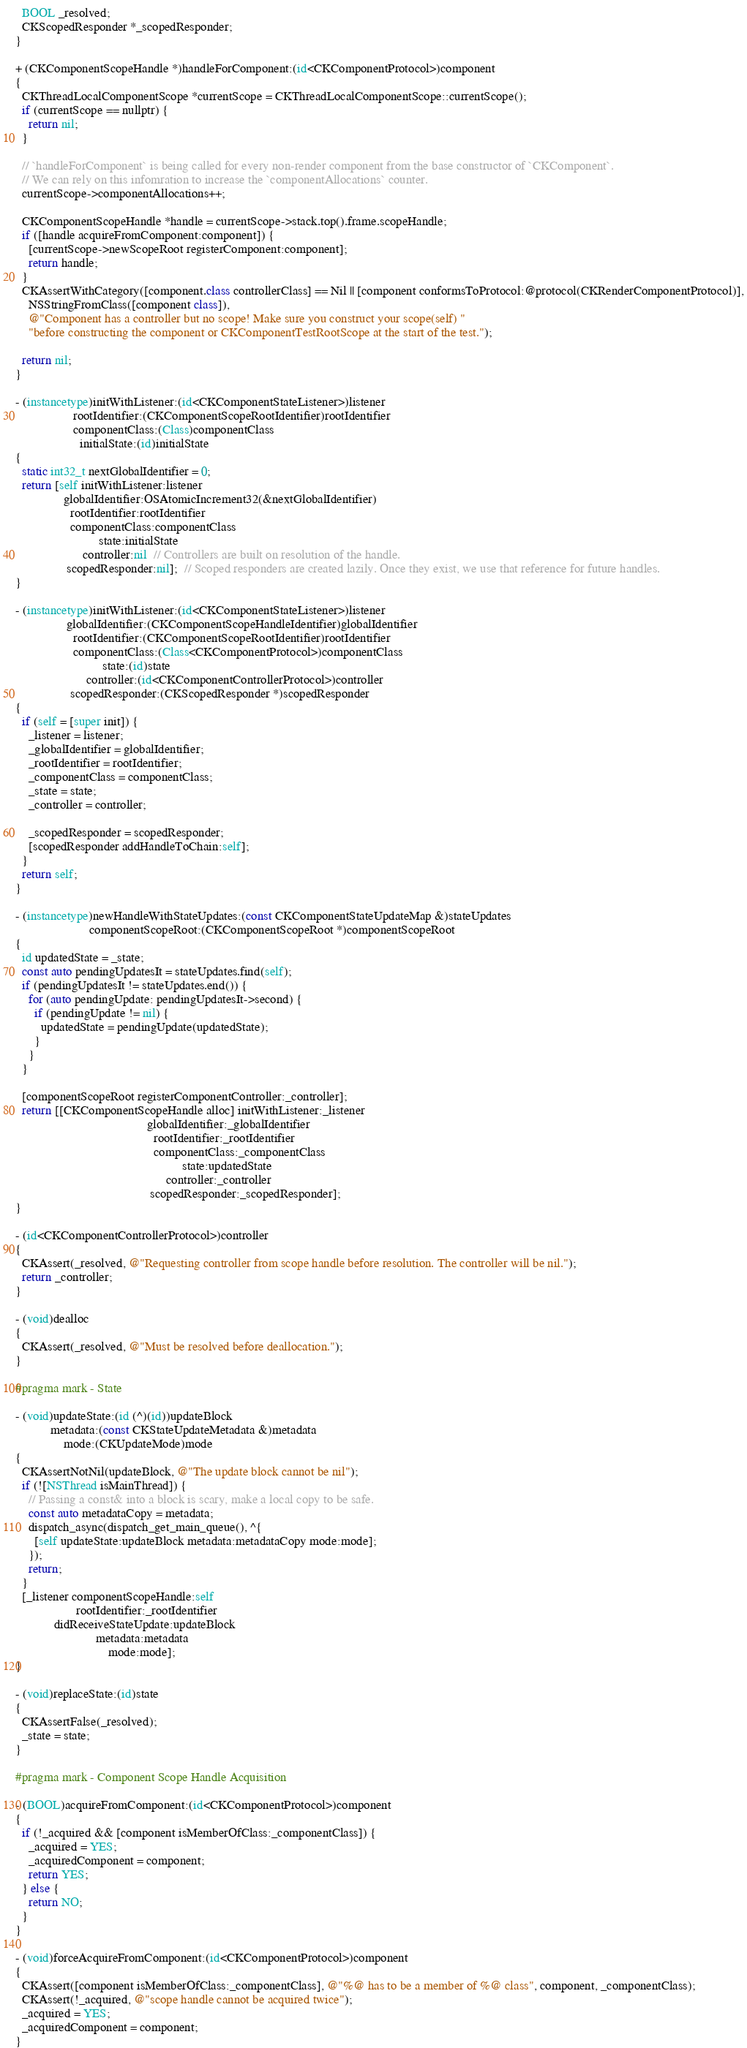<code> <loc_0><loc_0><loc_500><loc_500><_ObjectiveC_>  BOOL _resolved;
  CKScopedResponder *_scopedResponder;
}

+ (CKComponentScopeHandle *)handleForComponent:(id<CKComponentProtocol>)component
{
  CKThreadLocalComponentScope *currentScope = CKThreadLocalComponentScope::currentScope();
  if (currentScope == nullptr) {
    return nil;
  }

  // `handleForComponent` is being called for every non-render component from the base constructor of `CKComponent`.
  // We can rely on this infomration to increase the `componentAllocations` counter.
  currentScope->componentAllocations++;

  CKComponentScopeHandle *handle = currentScope->stack.top().frame.scopeHandle;
  if ([handle acquireFromComponent:component]) {
    [currentScope->newScopeRoot registerComponent:component];
    return handle;
  }
  CKAssertWithCategory([component.class controllerClass] == Nil || [component conformsToProtocol:@protocol(CKRenderComponentProtocol)],
    NSStringFromClass([component class]),
    @"Component has a controller but no scope! Make sure you construct your scope(self) "
    "before constructing the component or CKComponentTestRootScope at the start of the test.");

  return nil;
}

- (instancetype)initWithListener:(id<CKComponentStateListener>)listener
                  rootIdentifier:(CKComponentScopeRootIdentifier)rootIdentifier
                  componentClass:(Class)componentClass
                    initialState:(id)initialState
{
  static int32_t nextGlobalIdentifier = 0;
  return [self initWithListener:listener
               globalIdentifier:OSAtomicIncrement32(&nextGlobalIdentifier)
                 rootIdentifier:rootIdentifier
                 componentClass:componentClass
                          state:initialState
                     controller:nil  // Controllers are built on resolution of the handle.
                scopedResponder:nil];  // Scoped responders are created lazily. Once they exist, we use that reference for future handles.
}

- (instancetype)initWithListener:(id<CKComponentStateListener>)listener
                globalIdentifier:(CKComponentScopeHandleIdentifier)globalIdentifier
                  rootIdentifier:(CKComponentScopeRootIdentifier)rootIdentifier
                  componentClass:(Class<CKComponentProtocol>)componentClass
                           state:(id)state
                      controller:(id<CKComponentControllerProtocol>)controller
                 scopedResponder:(CKScopedResponder *)scopedResponder
{
  if (self = [super init]) {
    _listener = listener;
    _globalIdentifier = globalIdentifier;
    _rootIdentifier = rootIdentifier;
    _componentClass = componentClass;
    _state = state;
    _controller = controller;

    _scopedResponder = scopedResponder;
    [scopedResponder addHandleToChain:self];
  }
  return self;
}

- (instancetype)newHandleWithStateUpdates:(const CKComponentStateUpdateMap &)stateUpdates
                       componentScopeRoot:(CKComponentScopeRoot *)componentScopeRoot
{
  id updatedState = _state;
  const auto pendingUpdatesIt = stateUpdates.find(self);
  if (pendingUpdatesIt != stateUpdates.end()) {
    for (auto pendingUpdate: pendingUpdatesIt->second) {
      if (pendingUpdate != nil) {
        updatedState = pendingUpdate(updatedState);
      }
    }
  }

  [componentScopeRoot registerComponentController:_controller];
  return [[CKComponentScopeHandle alloc] initWithListener:_listener
                                         globalIdentifier:_globalIdentifier
                                           rootIdentifier:_rootIdentifier
                                           componentClass:_componentClass
                                                    state:updatedState
                                               controller:_controller
                                          scopedResponder:_scopedResponder];
}

- (id<CKComponentControllerProtocol>)controller
{
  CKAssert(_resolved, @"Requesting controller from scope handle before resolution. The controller will be nil.");
  return _controller;
}

- (void)dealloc
{
  CKAssert(_resolved, @"Must be resolved before deallocation.");
}

#pragma mark - State

- (void)updateState:(id (^)(id))updateBlock
           metadata:(const CKStateUpdateMetadata &)metadata
               mode:(CKUpdateMode)mode
{
  CKAssertNotNil(updateBlock, @"The update block cannot be nil");
  if (![NSThread isMainThread]) {
    // Passing a const& into a block is scary, make a local copy to be safe.
    const auto metadataCopy = metadata;
    dispatch_async(dispatch_get_main_queue(), ^{
      [self updateState:updateBlock metadata:metadataCopy mode:mode];
    });
    return;
  }
  [_listener componentScopeHandle:self
                   rootIdentifier:_rootIdentifier
            didReceiveStateUpdate:updateBlock
                         metadata:metadata
                             mode:mode];
}

- (void)replaceState:(id)state
{
  CKAssertFalse(_resolved);
  _state = state;
}

#pragma mark - Component Scope Handle Acquisition

- (BOOL)acquireFromComponent:(id<CKComponentProtocol>)component
{
  if (!_acquired && [component isMemberOfClass:_componentClass]) {
    _acquired = YES;
    _acquiredComponent = component;
    return YES;
  } else {
    return NO;
  }
}

- (void)forceAcquireFromComponent:(id<CKComponentProtocol>)component
{
  CKAssert([component isMemberOfClass:_componentClass], @"%@ has to be a member of %@ class", component, _componentClass);
  CKAssert(!_acquired, @"scope handle cannot be acquired twice");
  _acquired = YES;
  _acquiredComponent = component;
}
</code> 